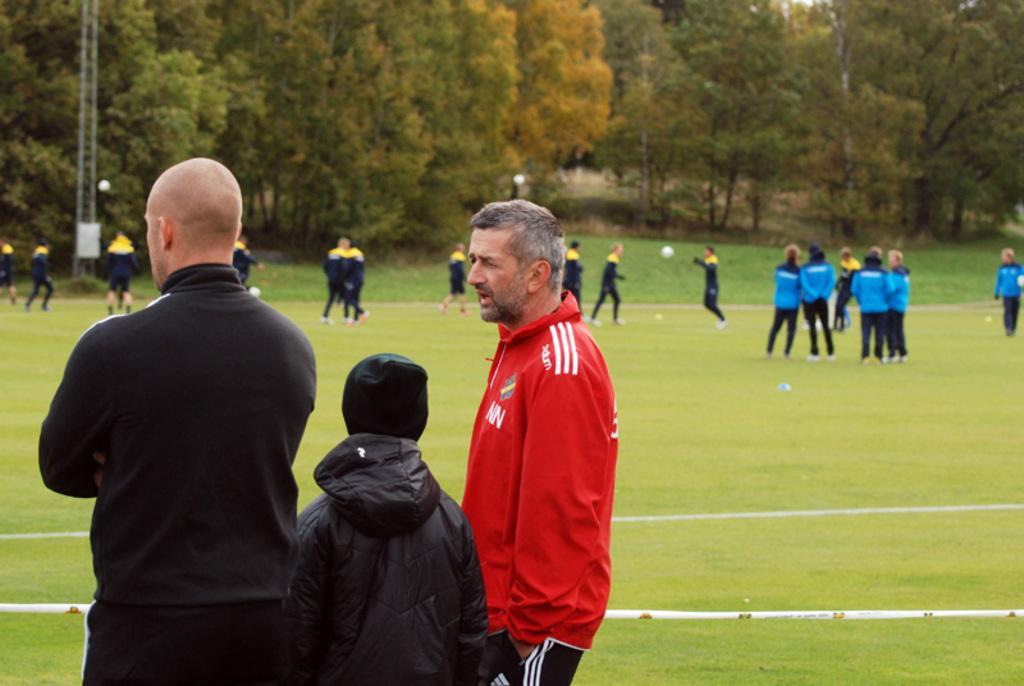In one or two sentences, can you explain what this image depicts? In this picture we can see three people and a boundary rope and we can see a group of people on the ground, here we can see an electric pole and balls and in the background we can see trees. 